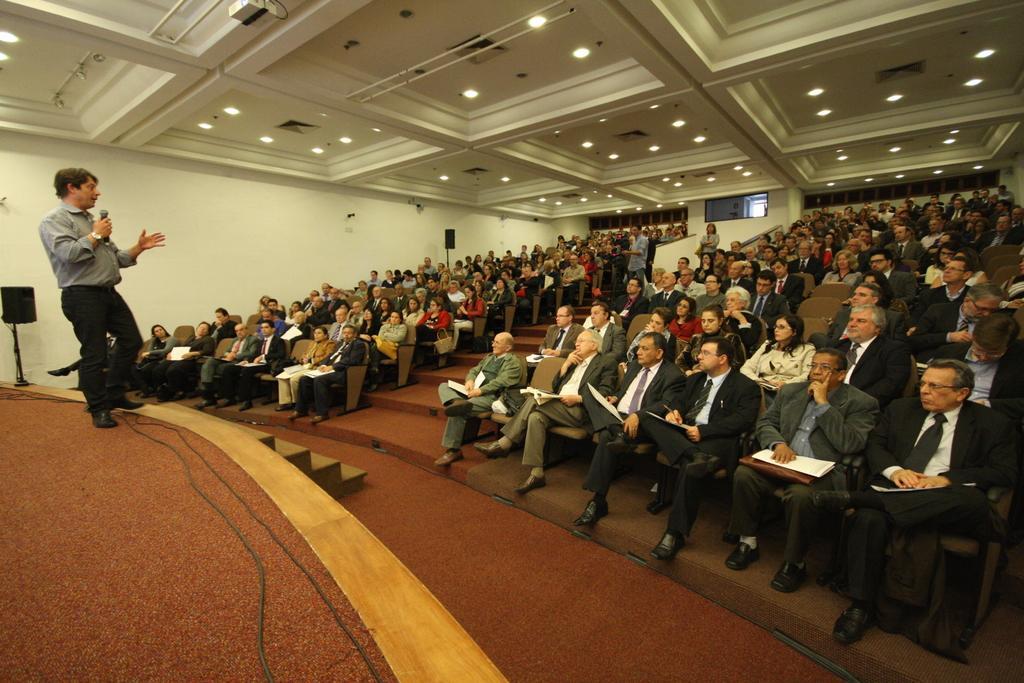In one or two sentences, can you explain what this image depicts? In this picture I can see group of people sitting on the chairs, there is a person standing and holding a mike, there are cables, there are speakers with the stands, there is a projector and there are lights. 